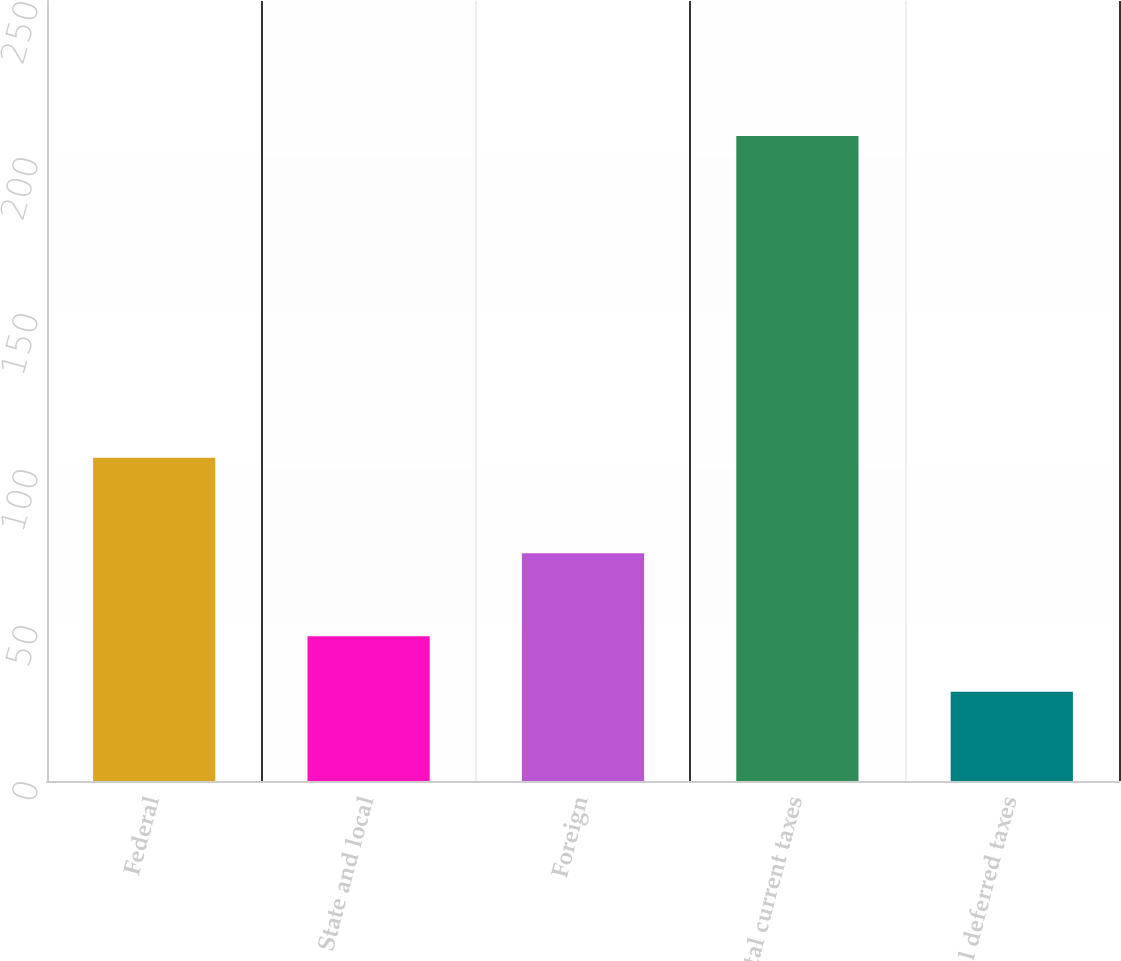Convert chart to OTSL. <chart><loc_0><loc_0><loc_500><loc_500><bar_chart><fcel>Federal<fcel>State and local<fcel>Foreign<fcel>Total current taxes<fcel>Total deferred taxes<nl><fcel>103.6<fcel>46.41<fcel>73<fcel>206.7<fcel>28.6<nl></chart> 